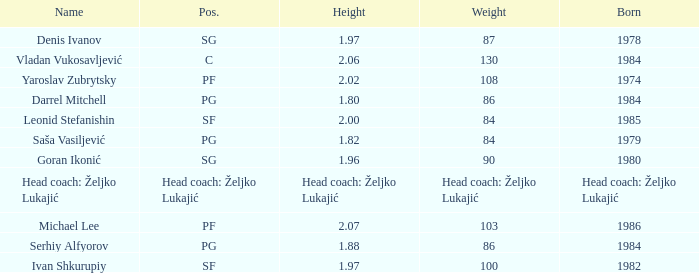What is the weight of the player with a height of 2.00m? 84.0. 